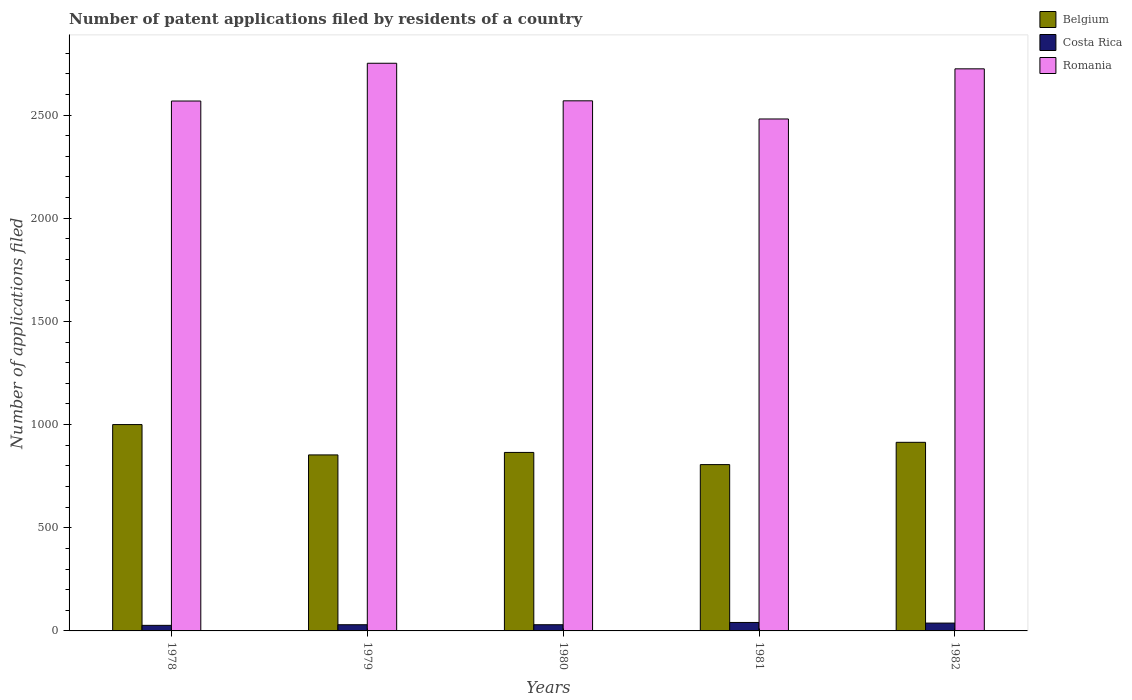How many different coloured bars are there?
Provide a succinct answer. 3. How many groups of bars are there?
Offer a terse response. 5. Are the number of bars per tick equal to the number of legend labels?
Keep it short and to the point. Yes. Are the number of bars on each tick of the X-axis equal?
Ensure brevity in your answer.  Yes. What is the label of the 5th group of bars from the left?
Provide a succinct answer. 1982. In how many cases, is the number of bars for a given year not equal to the number of legend labels?
Your answer should be compact. 0. Across all years, what is the maximum number of applications filed in Romania?
Your answer should be compact. 2751. Across all years, what is the minimum number of applications filed in Belgium?
Provide a short and direct response. 806. In which year was the number of applications filed in Romania maximum?
Your answer should be very brief. 1979. In which year was the number of applications filed in Costa Rica minimum?
Your response must be concise. 1978. What is the total number of applications filed in Romania in the graph?
Provide a short and direct response. 1.31e+04. What is the difference between the number of applications filed in Belgium in 1981 and the number of applications filed in Romania in 1982?
Ensure brevity in your answer.  -1918. What is the average number of applications filed in Romania per year?
Make the answer very short. 2618.6. In the year 1982, what is the difference between the number of applications filed in Romania and number of applications filed in Costa Rica?
Offer a terse response. 2686. What is the ratio of the number of applications filed in Costa Rica in 1978 to that in 1981?
Offer a very short reply. 0.66. Is the number of applications filed in Costa Rica in 1980 less than that in 1981?
Keep it short and to the point. Yes. Is the difference between the number of applications filed in Romania in 1978 and 1982 greater than the difference between the number of applications filed in Costa Rica in 1978 and 1982?
Your response must be concise. No. What is the difference between the highest and the lowest number of applications filed in Romania?
Make the answer very short. 270. In how many years, is the number of applications filed in Romania greater than the average number of applications filed in Romania taken over all years?
Offer a very short reply. 2. Is the sum of the number of applications filed in Belgium in 1980 and 1982 greater than the maximum number of applications filed in Romania across all years?
Make the answer very short. No. What does the 2nd bar from the left in 1979 represents?
Give a very brief answer. Costa Rica. What does the 3rd bar from the right in 1980 represents?
Your response must be concise. Belgium. Is it the case that in every year, the sum of the number of applications filed in Costa Rica and number of applications filed in Belgium is greater than the number of applications filed in Romania?
Give a very brief answer. No. Are all the bars in the graph horizontal?
Your answer should be very brief. No. How many years are there in the graph?
Provide a succinct answer. 5. Does the graph contain any zero values?
Offer a very short reply. No. How many legend labels are there?
Ensure brevity in your answer.  3. How are the legend labels stacked?
Your response must be concise. Vertical. What is the title of the graph?
Offer a terse response. Number of patent applications filed by residents of a country. Does "Turks and Caicos Islands" appear as one of the legend labels in the graph?
Your answer should be very brief. No. What is the label or title of the X-axis?
Your response must be concise. Years. What is the label or title of the Y-axis?
Offer a very short reply. Number of applications filed. What is the Number of applications filed in Belgium in 1978?
Provide a short and direct response. 1000. What is the Number of applications filed of Costa Rica in 1978?
Make the answer very short. 27. What is the Number of applications filed of Romania in 1978?
Keep it short and to the point. 2568. What is the Number of applications filed of Belgium in 1979?
Offer a very short reply. 853. What is the Number of applications filed in Costa Rica in 1979?
Keep it short and to the point. 30. What is the Number of applications filed in Romania in 1979?
Offer a very short reply. 2751. What is the Number of applications filed of Belgium in 1980?
Your answer should be compact. 865. What is the Number of applications filed in Romania in 1980?
Your answer should be compact. 2569. What is the Number of applications filed of Belgium in 1981?
Provide a short and direct response. 806. What is the Number of applications filed of Costa Rica in 1981?
Provide a succinct answer. 41. What is the Number of applications filed in Romania in 1981?
Give a very brief answer. 2481. What is the Number of applications filed in Belgium in 1982?
Give a very brief answer. 914. What is the Number of applications filed in Costa Rica in 1982?
Provide a short and direct response. 38. What is the Number of applications filed of Romania in 1982?
Ensure brevity in your answer.  2724. Across all years, what is the maximum Number of applications filed of Belgium?
Your response must be concise. 1000. Across all years, what is the maximum Number of applications filed in Romania?
Provide a succinct answer. 2751. Across all years, what is the minimum Number of applications filed in Belgium?
Ensure brevity in your answer.  806. Across all years, what is the minimum Number of applications filed of Costa Rica?
Make the answer very short. 27. Across all years, what is the minimum Number of applications filed of Romania?
Ensure brevity in your answer.  2481. What is the total Number of applications filed in Belgium in the graph?
Offer a terse response. 4438. What is the total Number of applications filed in Costa Rica in the graph?
Your response must be concise. 166. What is the total Number of applications filed in Romania in the graph?
Your answer should be compact. 1.31e+04. What is the difference between the Number of applications filed of Belgium in 1978 and that in 1979?
Give a very brief answer. 147. What is the difference between the Number of applications filed of Romania in 1978 and that in 1979?
Keep it short and to the point. -183. What is the difference between the Number of applications filed in Belgium in 1978 and that in 1980?
Provide a short and direct response. 135. What is the difference between the Number of applications filed of Belgium in 1978 and that in 1981?
Offer a terse response. 194. What is the difference between the Number of applications filed of Romania in 1978 and that in 1981?
Your response must be concise. 87. What is the difference between the Number of applications filed of Romania in 1978 and that in 1982?
Your response must be concise. -156. What is the difference between the Number of applications filed of Belgium in 1979 and that in 1980?
Provide a succinct answer. -12. What is the difference between the Number of applications filed in Romania in 1979 and that in 1980?
Offer a very short reply. 182. What is the difference between the Number of applications filed in Costa Rica in 1979 and that in 1981?
Your answer should be compact. -11. What is the difference between the Number of applications filed of Romania in 1979 and that in 1981?
Provide a succinct answer. 270. What is the difference between the Number of applications filed in Belgium in 1979 and that in 1982?
Offer a very short reply. -61. What is the difference between the Number of applications filed of Costa Rica in 1979 and that in 1982?
Offer a terse response. -8. What is the difference between the Number of applications filed in Romania in 1979 and that in 1982?
Offer a very short reply. 27. What is the difference between the Number of applications filed in Belgium in 1980 and that in 1982?
Give a very brief answer. -49. What is the difference between the Number of applications filed in Costa Rica in 1980 and that in 1982?
Keep it short and to the point. -8. What is the difference between the Number of applications filed of Romania in 1980 and that in 1982?
Make the answer very short. -155. What is the difference between the Number of applications filed of Belgium in 1981 and that in 1982?
Keep it short and to the point. -108. What is the difference between the Number of applications filed of Costa Rica in 1981 and that in 1982?
Provide a short and direct response. 3. What is the difference between the Number of applications filed of Romania in 1981 and that in 1982?
Offer a terse response. -243. What is the difference between the Number of applications filed in Belgium in 1978 and the Number of applications filed in Costa Rica in 1979?
Provide a succinct answer. 970. What is the difference between the Number of applications filed in Belgium in 1978 and the Number of applications filed in Romania in 1979?
Make the answer very short. -1751. What is the difference between the Number of applications filed in Costa Rica in 1978 and the Number of applications filed in Romania in 1979?
Your answer should be compact. -2724. What is the difference between the Number of applications filed in Belgium in 1978 and the Number of applications filed in Costa Rica in 1980?
Keep it short and to the point. 970. What is the difference between the Number of applications filed of Belgium in 1978 and the Number of applications filed of Romania in 1980?
Your answer should be very brief. -1569. What is the difference between the Number of applications filed of Costa Rica in 1978 and the Number of applications filed of Romania in 1980?
Keep it short and to the point. -2542. What is the difference between the Number of applications filed of Belgium in 1978 and the Number of applications filed of Costa Rica in 1981?
Ensure brevity in your answer.  959. What is the difference between the Number of applications filed in Belgium in 1978 and the Number of applications filed in Romania in 1981?
Give a very brief answer. -1481. What is the difference between the Number of applications filed in Costa Rica in 1978 and the Number of applications filed in Romania in 1981?
Offer a terse response. -2454. What is the difference between the Number of applications filed of Belgium in 1978 and the Number of applications filed of Costa Rica in 1982?
Give a very brief answer. 962. What is the difference between the Number of applications filed of Belgium in 1978 and the Number of applications filed of Romania in 1982?
Ensure brevity in your answer.  -1724. What is the difference between the Number of applications filed in Costa Rica in 1978 and the Number of applications filed in Romania in 1982?
Provide a succinct answer. -2697. What is the difference between the Number of applications filed of Belgium in 1979 and the Number of applications filed of Costa Rica in 1980?
Provide a succinct answer. 823. What is the difference between the Number of applications filed of Belgium in 1979 and the Number of applications filed of Romania in 1980?
Make the answer very short. -1716. What is the difference between the Number of applications filed in Costa Rica in 1979 and the Number of applications filed in Romania in 1980?
Your answer should be very brief. -2539. What is the difference between the Number of applications filed of Belgium in 1979 and the Number of applications filed of Costa Rica in 1981?
Keep it short and to the point. 812. What is the difference between the Number of applications filed of Belgium in 1979 and the Number of applications filed of Romania in 1981?
Offer a very short reply. -1628. What is the difference between the Number of applications filed in Costa Rica in 1979 and the Number of applications filed in Romania in 1981?
Your answer should be compact. -2451. What is the difference between the Number of applications filed of Belgium in 1979 and the Number of applications filed of Costa Rica in 1982?
Give a very brief answer. 815. What is the difference between the Number of applications filed of Belgium in 1979 and the Number of applications filed of Romania in 1982?
Your answer should be compact. -1871. What is the difference between the Number of applications filed of Costa Rica in 1979 and the Number of applications filed of Romania in 1982?
Keep it short and to the point. -2694. What is the difference between the Number of applications filed of Belgium in 1980 and the Number of applications filed of Costa Rica in 1981?
Offer a very short reply. 824. What is the difference between the Number of applications filed in Belgium in 1980 and the Number of applications filed in Romania in 1981?
Offer a terse response. -1616. What is the difference between the Number of applications filed in Costa Rica in 1980 and the Number of applications filed in Romania in 1981?
Ensure brevity in your answer.  -2451. What is the difference between the Number of applications filed in Belgium in 1980 and the Number of applications filed in Costa Rica in 1982?
Offer a very short reply. 827. What is the difference between the Number of applications filed of Belgium in 1980 and the Number of applications filed of Romania in 1982?
Provide a succinct answer. -1859. What is the difference between the Number of applications filed of Costa Rica in 1980 and the Number of applications filed of Romania in 1982?
Your answer should be compact. -2694. What is the difference between the Number of applications filed in Belgium in 1981 and the Number of applications filed in Costa Rica in 1982?
Your response must be concise. 768. What is the difference between the Number of applications filed of Belgium in 1981 and the Number of applications filed of Romania in 1982?
Offer a terse response. -1918. What is the difference between the Number of applications filed of Costa Rica in 1981 and the Number of applications filed of Romania in 1982?
Give a very brief answer. -2683. What is the average Number of applications filed of Belgium per year?
Provide a short and direct response. 887.6. What is the average Number of applications filed of Costa Rica per year?
Give a very brief answer. 33.2. What is the average Number of applications filed of Romania per year?
Offer a terse response. 2618.6. In the year 1978, what is the difference between the Number of applications filed of Belgium and Number of applications filed of Costa Rica?
Make the answer very short. 973. In the year 1978, what is the difference between the Number of applications filed in Belgium and Number of applications filed in Romania?
Offer a terse response. -1568. In the year 1978, what is the difference between the Number of applications filed of Costa Rica and Number of applications filed of Romania?
Offer a terse response. -2541. In the year 1979, what is the difference between the Number of applications filed in Belgium and Number of applications filed in Costa Rica?
Make the answer very short. 823. In the year 1979, what is the difference between the Number of applications filed in Belgium and Number of applications filed in Romania?
Provide a succinct answer. -1898. In the year 1979, what is the difference between the Number of applications filed in Costa Rica and Number of applications filed in Romania?
Give a very brief answer. -2721. In the year 1980, what is the difference between the Number of applications filed of Belgium and Number of applications filed of Costa Rica?
Offer a terse response. 835. In the year 1980, what is the difference between the Number of applications filed of Belgium and Number of applications filed of Romania?
Make the answer very short. -1704. In the year 1980, what is the difference between the Number of applications filed of Costa Rica and Number of applications filed of Romania?
Make the answer very short. -2539. In the year 1981, what is the difference between the Number of applications filed in Belgium and Number of applications filed in Costa Rica?
Provide a short and direct response. 765. In the year 1981, what is the difference between the Number of applications filed of Belgium and Number of applications filed of Romania?
Your response must be concise. -1675. In the year 1981, what is the difference between the Number of applications filed of Costa Rica and Number of applications filed of Romania?
Keep it short and to the point. -2440. In the year 1982, what is the difference between the Number of applications filed in Belgium and Number of applications filed in Costa Rica?
Your answer should be very brief. 876. In the year 1982, what is the difference between the Number of applications filed of Belgium and Number of applications filed of Romania?
Provide a short and direct response. -1810. In the year 1982, what is the difference between the Number of applications filed in Costa Rica and Number of applications filed in Romania?
Your response must be concise. -2686. What is the ratio of the Number of applications filed of Belgium in 1978 to that in 1979?
Provide a short and direct response. 1.17. What is the ratio of the Number of applications filed in Costa Rica in 1978 to that in 1979?
Ensure brevity in your answer.  0.9. What is the ratio of the Number of applications filed of Romania in 1978 to that in 1979?
Provide a succinct answer. 0.93. What is the ratio of the Number of applications filed of Belgium in 1978 to that in 1980?
Make the answer very short. 1.16. What is the ratio of the Number of applications filed of Romania in 1978 to that in 1980?
Offer a terse response. 1. What is the ratio of the Number of applications filed of Belgium in 1978 to that in 1981?
Ensure brevity in your answer.  1.24. What is the ratio of the Number of applications filed in Costa Rica in 1978 to that in 1981?
Provide a succinct answer. 0.66. What is the ratio of the Number of applications filed in Romania in 1978 to that in 1981?
Keep it short and to the point. 1.04. What is the ratio of the Number of applications filed of Belgium in 1978 to that in 1982?
Offer a very short reply. 1.09. What is the ratio of the Number of applications filed in Costa Rica in 1978 to that in 1982?
Ensure brevity in your answer.  0.71. What is the ratio of the Number of applications filed in Romania in 1978 to that in 1982?
Give a very brief answer. 0.94. What is the ratio of the Number of applications filed in Belgium in 1979 to that in 1980?
Give a very brief answer. 0.99. What is the ratio of the Number of applications filed in Costa Rica in 1979 to that in 1980?
Your answer should be compact. 1. What is the ratio of the Number of applications filed in Romania in 1979 to that in 1980?
Give a very brief answer. 1.07. What is the ratio of the Number of applications filed of Belgium in 1979 to that in 1981?
Provide a succinct answer. 1.06. What is the ratio of the Number of applications filed of Costa Rica in 1979 to that in 1981?
Your answer should be compact. 0.73. What is the ratio of the Number of applications filed of Romania in 1979 to that in 1981?
Your response must be concise. 1.11. What is the ratio of the Number of applications filed in Belgium in 1979 to that in 1982?
Keep it short and to the point. 0.93. What is the ratio of the Number of applications filed in Costa Rica in 1979 to that in 1982?
Make the answer very short. 0.79. What is the ratio of the Number of applications filed in Romania in 1979 to that in 1982?
Give a very brief answer. 1.01. What is the ratio of the Number of applications filed in Belgium in 1980 to that in 1981?
Offer a terse response. 1.07. What is the ratio of the Number of applications filed in Costa Rica in 1980 to that in 1981?
Offer a terse response. 0.73. What is the ratio of the Number of applications filed of Romania in 1980 to that in 1981?
Make the answer very short. 1.04. What is the ratio of the Number of applications filed of Belgium in 1980 to that in 1982?
Your response must be concise. 0.95. What is the ratio of the Number of applications filed in Costa Rica in 1980 to that in 1982?
Give a very brief answer. 0.79. What is the ratio of the Number of applications filed in Romania in 1980 to that in 1982?
Make the answer very short. 0.94. What is the ratio of the Number of applications filed of Belgium in 1981 to that in 1982?
Your answer should be very brief. 0.88. What is the ratio of the Number of applications filed in Costa Rica in 1981 to that in 1982?
Your answer should be very brief. 1.08. What is the ratio of the Number of applications filed in Romania in 1981 to that in 1982?
Make the answer very short. 0.91. What is the difference between the highest and the second highest Number of applications filed in Costa Rica?
Ensure brevity in your answer.  3. What is the difference between the highest and the second highest Number of applications filed in Romania?
Your answer should be compact. 27. What is the difference between the highest and the lowest Number of applications filed in Belgium?
Offer a very short reply. 194. What is the difference between the highest and the lowest Number of applications filed of Romania?
Your answer should be compact. 270. 